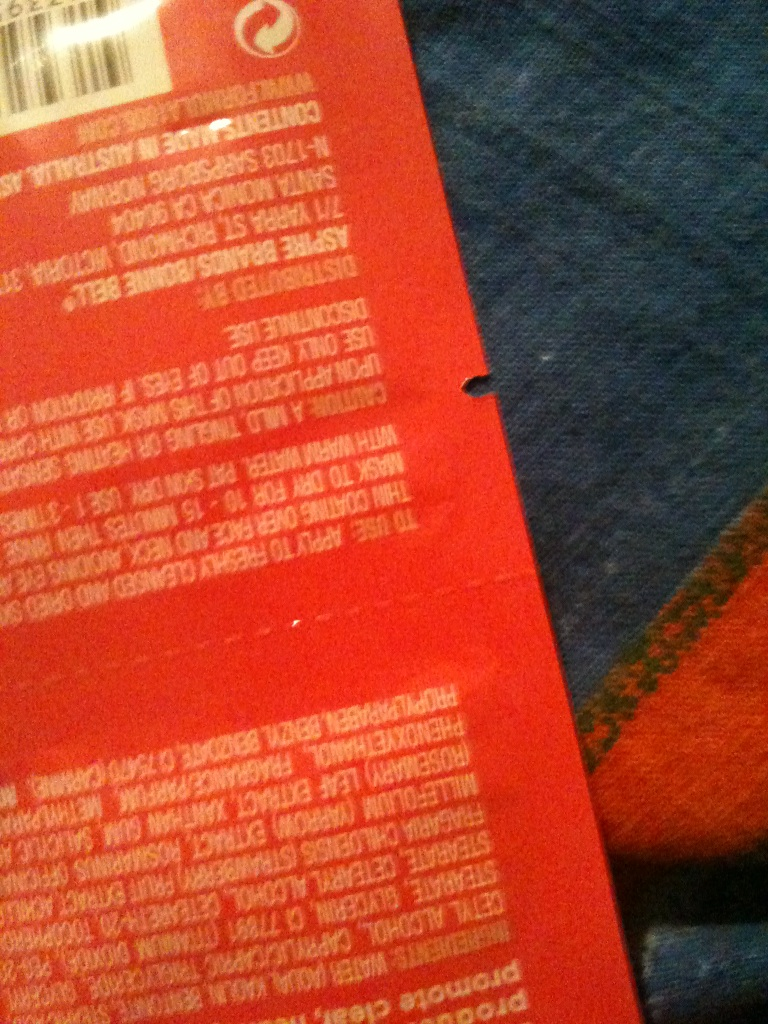Based on the shape and size of the bottle, what type of product would you guess this is? The shape of the bottle seems to be tall and possibly cylindrical, which is typical for many shampoo or conditioner bottles. The size is hard to ascertain without a reference, but it seems to be a standard size for personal care products.  Is there anything else on the package, like symbols or logos, that could help us identify the product? Due to the low resolution of the image, it's difficult to make out specific logos or symbols. However, a barcode is visible, which is a standard feature on commercial products. A clearer image or a barcode scan might provide definitive product information. 